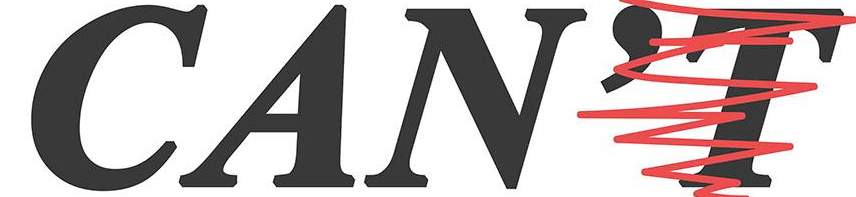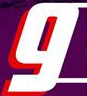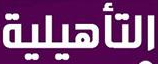What words can you see in these images in sequence, separated by a semicolon? CAN'T; g; ### 